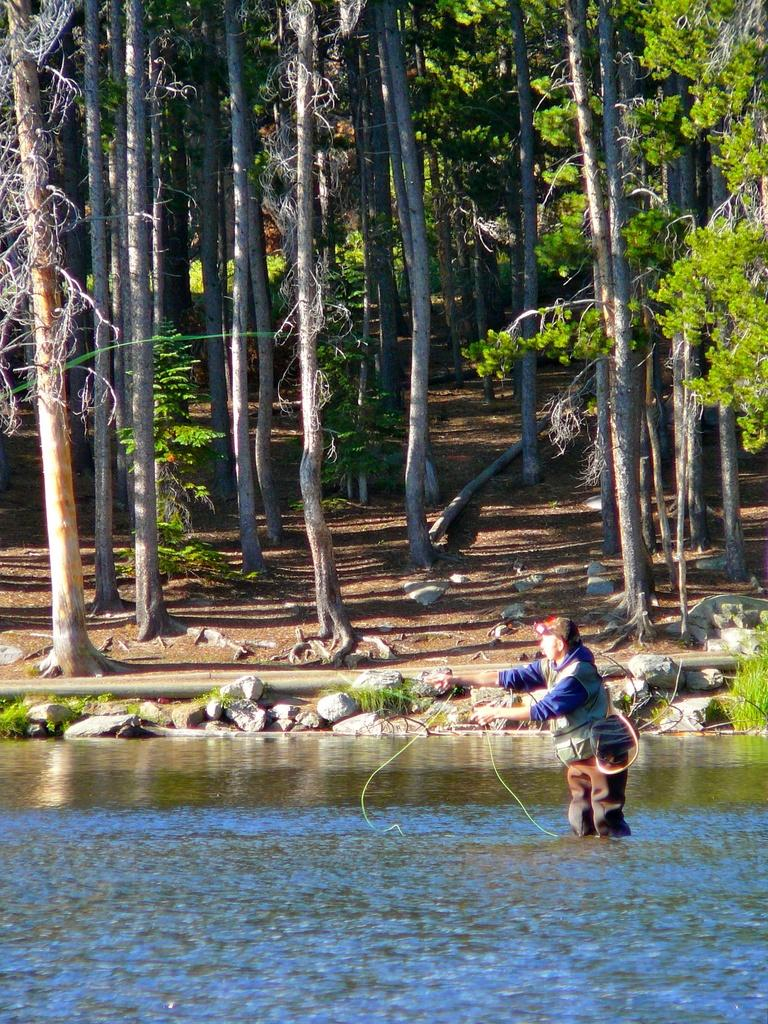What is in the front of the image? There is water in the front of the image. What is the person in the image doing? There is a person standing in the water. What can be seen in the background of the image? There are trees in the background of the image. What type of objects are present in the water? There are stones in the image. What type of yarn is being used by the person standing in the water? There is no yarn present in the image, and the person standing in the water is not using any yarn. How many birds are in the flock that is visible in the image? There is no flock of birds present in the image. 